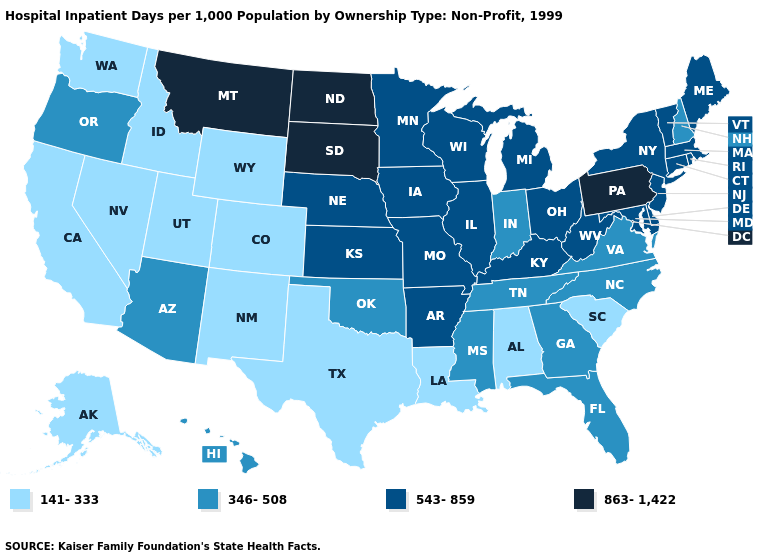Does Maryland have the highest value in the South?
Keep it brief. Yes. Which states have the lowest value in the USA?
Write a very short answer. Alabama, Alaska, California, Colorado, Idaho, Louisiana, Nevada, New Mexico, South Carolina, Texas, Utah, Washington, Wyoming. Which states hav the highest value in the MidWest?
Keep it brief. North Dakota, South Dakota. What is the value of Washington?
Quick response, please. 141-333. Among the states that border Arkansas , which have the lowest value?
Quick response, please. Louisiana, Texas. What is the lowest value in the USA?
Be succinct. 141-333. What is the value of Delaware?
Concise answer only. 543-859. Does Maine have the lowest value in the USA?
Short answer required. No. Name the states that have a value in the range 863-1,422?
Quick response, please. Montana, North Dakota, Pennsylvania, South Dakota. Among the states that border Georgia , which have the highest value?
Quick response, please. Florida, North Carolina, Tennessee. Name the states that have a value in the range 543-859?
Concise answer only. Arkansas, Connecticut, Delaware, Illinois, Iowa, Kansas, Kentucky, Maine, Maryland, Massachusetts, Michigan, Minnesota, Missouri, Nebraska, New Jersey, New York, Ohio, Rhode Island, Vermont, West Virginia, Wisconsin. What is the value of South Carolina?
Be succinct. 141-333. Name the states that have a value in the range 141-333?
Quick response, please. Alabama, Alaska, California, Colorado, Idaho, Louisiana, Nevada, New Mexico, South Carolina, Texas, Utah, Washington, Wyoming. What is the lowest value in states that border Florida?
Be succinct. 141-333. What is the lowest value in states that border Louisiana?
Be succinct. 141-333. 